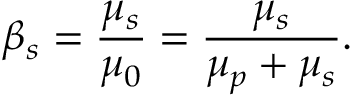Convert formula to latex. <formula><loc_0><loc_0><loc_500><loc_500>\beta _ { s } = \frac { \mu _ { s } } { \mu _ { 0 } } = \frac { \mu _ { s } } { \mu _ { p } + \mu _ { s } } .</formula> 